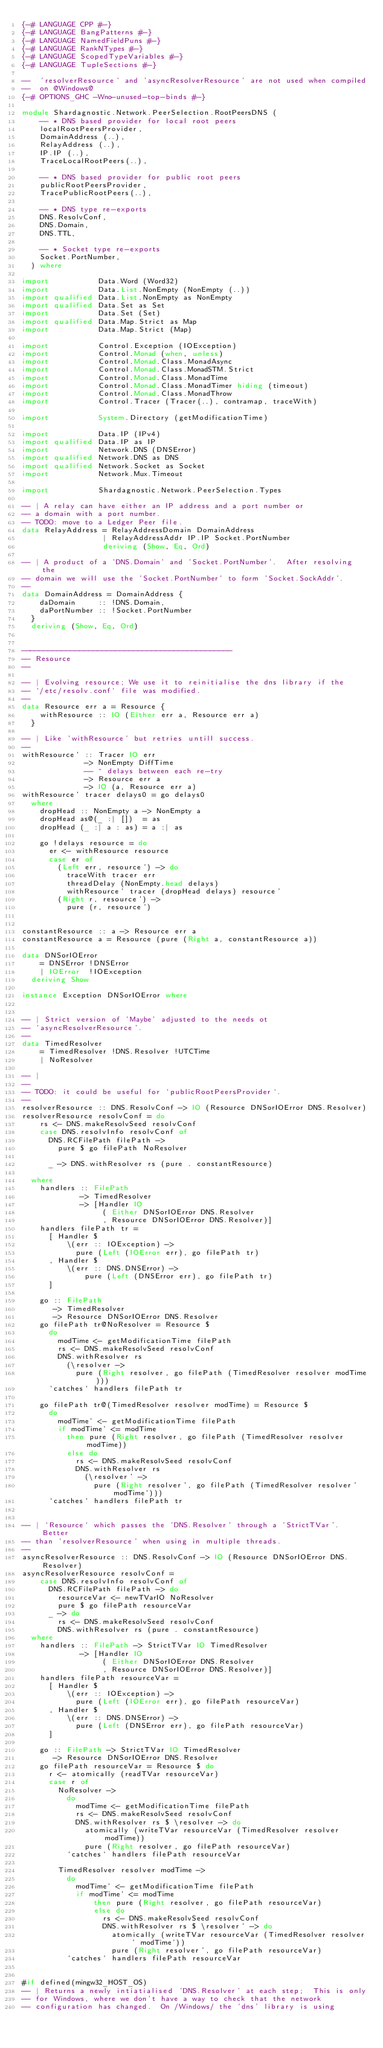<code> <loc_0><loc_0><loc_500><loc_500><_Haskell_>{-# LANGUAGE CPP #-}
{-# LANGUAGE BangPatterns #-}
{-# LANGUAGE NamedFieldPuns #-}
{-# LANGUAGE RankNTypes #-}
{-# LANGUAGE ScopedTypeVariables #-}
{-# LANGUAGE TupleSections #-}

--  'resolverResource' and 'asyncResolverResource' are not used when compiled
--  on @Windows@
{-# OPTIONS_GHC -Wno-unused-top-binds #-}

module Shardagnostic.Network.PeerSelection.RootPeersDNS (
    -- * DNS based provider for local root peers
    localRootPeersProvider,
    DomainAddress (..),
    RelayAddress (..),
    IP.IP (..),
    TraceLocalRootPeers(..),

    -- * DNS based provider for public root peers
    publicRootPeersProvider,
    TracePublicRootPeers(..),

    -- * DNS type re-exports
    DNS.ResolvConf,
    DNS.Domain,
    DNS.TTL,

    -- * Socket type re-exports
    Socket.PortNumber,
  ) where

import           Data.Word (Word32)
import           Data.List.NonEmpty (NonEmpty (..))
import qualified Data.List.NonEmpty as NonEmpty
import qualified Data.Set as Set
import           Data.Set (Set)
import qualified Data.Map.Strict as Map
import           Data.Map.Strict (Map)

import           Control.Exception (IOException)
import           Control.Monad (when, unless)
import           Control.Monad.Class.MonadAsync
import           Control.Monad.Class.MonadSTM.Strict
import           Control.Monad.Class.MonadTime
import           Control.Monad.Class.MonadTimer hiding (timeout)
import           Control.Monad.Class.MonadThrow
import           Control.Tracer (Tracer(..), contramap, traceWith)

import           System.Directory (getModificationTime)

import           Data.IP (IPv4)
import qualified Data.IP as IP
import           Network.DNS (DNSError)
import qualified Network.DNS as DNS
import qualified Network.Socket as Socket
import           Network.Mux.Timeout

import           Shardagnostic.Network.PeerSelection.Types

-- | A relay can have either an IP address and a port number or
-- a domain with a port number.
-- TODO: move to a Ledger Peer file.
data RelayAddress = RelayAddressDomain DomainAddress
                  | RelayAddressAddr IP.IP Socket.PortNumber
                  deriving (Show, Eq, Ord)

-- | A product of a 'DNS.Domain' and 'Socket.PortNumber'.  After resolving the
-- domain we will use the 'Socket.PortNumber' to form 'Socket.SockAddr'.
--
data DomainAddress = DomainAddress {
    daDomain     :: !DNS.Domain,
    daPortNumber :: !Socket.PortNumber
  }
  deriving (Show, Eq, Ord)


-----------------------------------------------
-- Resource
--

-- | Evolving resource; We use it to reinitialise the dns library if the
-- `/etc/resolv.conf` file was modified.
--
data Resource err a = Resource {
    withResource :: IO (Either err a, Resource err a)
  }

-- | Like 'withResource' but retries untill success.
--
withResource' :: Tracer IO err
              -> NonEmpty DiffTime
              -- ^ delays between each re-try
              -> Resource err a
              -> IO (a, Resource err a)
withResource' tracer delays0 = go delays0
  where
    dropHead :: NonEmpty a -> NonEmpty a
    dropHead as@(_ :| [])  = as
    dropHead (_ :| a : as) = a :| as

    go !delays resource = do
      er <- withResource resource
      case er of
        (Left err, resource') -> do
          traceWith tracer err
          threadDelay (NonEmpty.head delays)
          withResource' tracer (dropHead delays) resource'
        (Right r, resource') ->
          pure (r, resource')


constantResource :: a -> Resource err a
constantResource a = Resource (pure (Right a, constantResource a))

data DNSorIOError
    = DNSError !DNSError
    | IOError  !IOException
  deriving Show

instance Exception DNSorIOError where


-- | Strict version of 'Maybe' adjusted to the needs ot
-- 'asyncResolverResource'.
--
data TimedResolver
    = TimedResolver !DNS.Resolver !UTCTime
    | NoResolver

-- |
--
-- TODO: it could be useful for `publicRootPeersProvider`.
--
resolverResource :: DNS.ResolvConf -> IO (Resource DNSorIOError DNS.Resolver)
resolverResource resolvConf = do
    rs <- DNS.makeResolvSeed resolvConf
    case DNS.resolvInfo resolvConf of
      DNS.RCFilePath filePath ->
        pure $ go filePath NoResolver

      _ -> DNS.withResolver rs (pure . constantResource)

  where
    handlers :: FilePath
             -> TimedResolver
             -> [Handler IO
                  ( Either DNSorIOError DNS.Resolver
                  , Resource DNSorIOError DNS.Resolver)]
    handlers filePath tr =
      [ Handler $
          \(err :: IOException) ->
            pure (Left (IOError err), go filePath tr)
      , Handler $
          \(err :: DNS.DNSError) ->
              pure (Left (DNSError err), go filePath tr)
      ]

    go :: FilePath
       -> TimedResolver
       -> Resource DNSorIOError DNS.Resolver
    go filePath tr@NoResolver = Resource $
      do
        modTime <- getModificationTime filePath
        rs <- DNS.makeResolvSeed resolvConf
        DNS.withResolver rs
          (\resolver ->
            pure (Right resolver, go filePath (TimedResolver resolver modTime)))
      `catches` handlers filePath tr

    go filePath tr@(TimedResolver resolver modTime) = Resource $
      do
        modTime' <- getModificationTime filePath
        if modTime' <= modTime
          then pure (Right resolver, go filePath (TimedResolver resolver modTime))
          else do
            rs <- DNS.makeResolvSeed resolvConf
            DNS.withResolver rs
              (\resolver' ->
                pure (Right resolver', go filePath (TimedResolver resolver' modTime')))
      `catches` handlers filePath tr


-- | `Resource` which passes the 'DNS.Resolver' through a 'StrictTVar'.  Better
-- than 'resolverResource' when using in multiple threads.
--
asyncResolverResource :: DNS.ResolvConf -> IO (Resource DNSorIOError DNS.Resolver)
asyncResolverResource resolvConf =
    case DNS.resolvInfo resolvConf of
      DNS.RCFilePath filePath -> do
        resourceVar <- newTVarIO NoResolver
        pure $ go filePath resourceVar
      _ -> do
        rs <- DNS.makeResolvSeed resolvConf
        DNS.withResolver rs (pure . constantResource)
  where
    handlers :: FilePath -> StrictTVar IO TimedResolver
             -> [Handler IO
                  ( Either DNSorIOError DNS.Resolver
                  , Resource DNSorIOError DNS.Resolver)]
    handlers filePath resourceVar =
      [ Handler $
          \(err :: IOException) ->
            pure (Left (IOError err), go filePath resourceVar)
      , Handler $
          \(err :: DNS.DNSError) ->
            pure (Left (DNSError err), go filePath resourceVar)
      ]

    go :: FilePath -> StrictTVar IO TimedResolver
       -> Resource DNSorIOError DNS.Resolver
    go filePath resourceVar = Resource $ do
      r <- atomically (readTVar resourceVar)
      case r of
        NoResolver ->
          do
            modTime <- getModificationTime filePath
            rs <- DNS.makeResolvSeed resolvConf
            DNS.withResolver rs $ \resolver -> do
              atomically (writeTVar resourceVar (TimedResolver resolver modTime))
              pure (Right resolver, go filePath resourceVar)
          `catches` handlers filePath resourceVar

        TimedResolver resolver modTime ->
          do
            modTime' <- getModificationTime filePath
            if modTime' <= modTime
                then pure (Right resolver, go filePath resourceVar)
                else do
                  rs <- DNS.makeResolvSeed resolvConf
                  DNS.withResolver rs $ \resolver' -> do
                    atomically (writeTVar resourceVar (TimedResolver resolver' modTime'))
                    pure (Right resolver', go filePath resourceVar)
          `catches` handlers filePath resourceVar


#if defined(mingw32_HOST_OS)
-- | Returns a newly intiatialised 'DNS.Resolver' at each step;  This is only
-- for Windows, where we don't have a way to check that the network
-- configuration has changed.  On /Windows/ the 'dns' library is using</code> 